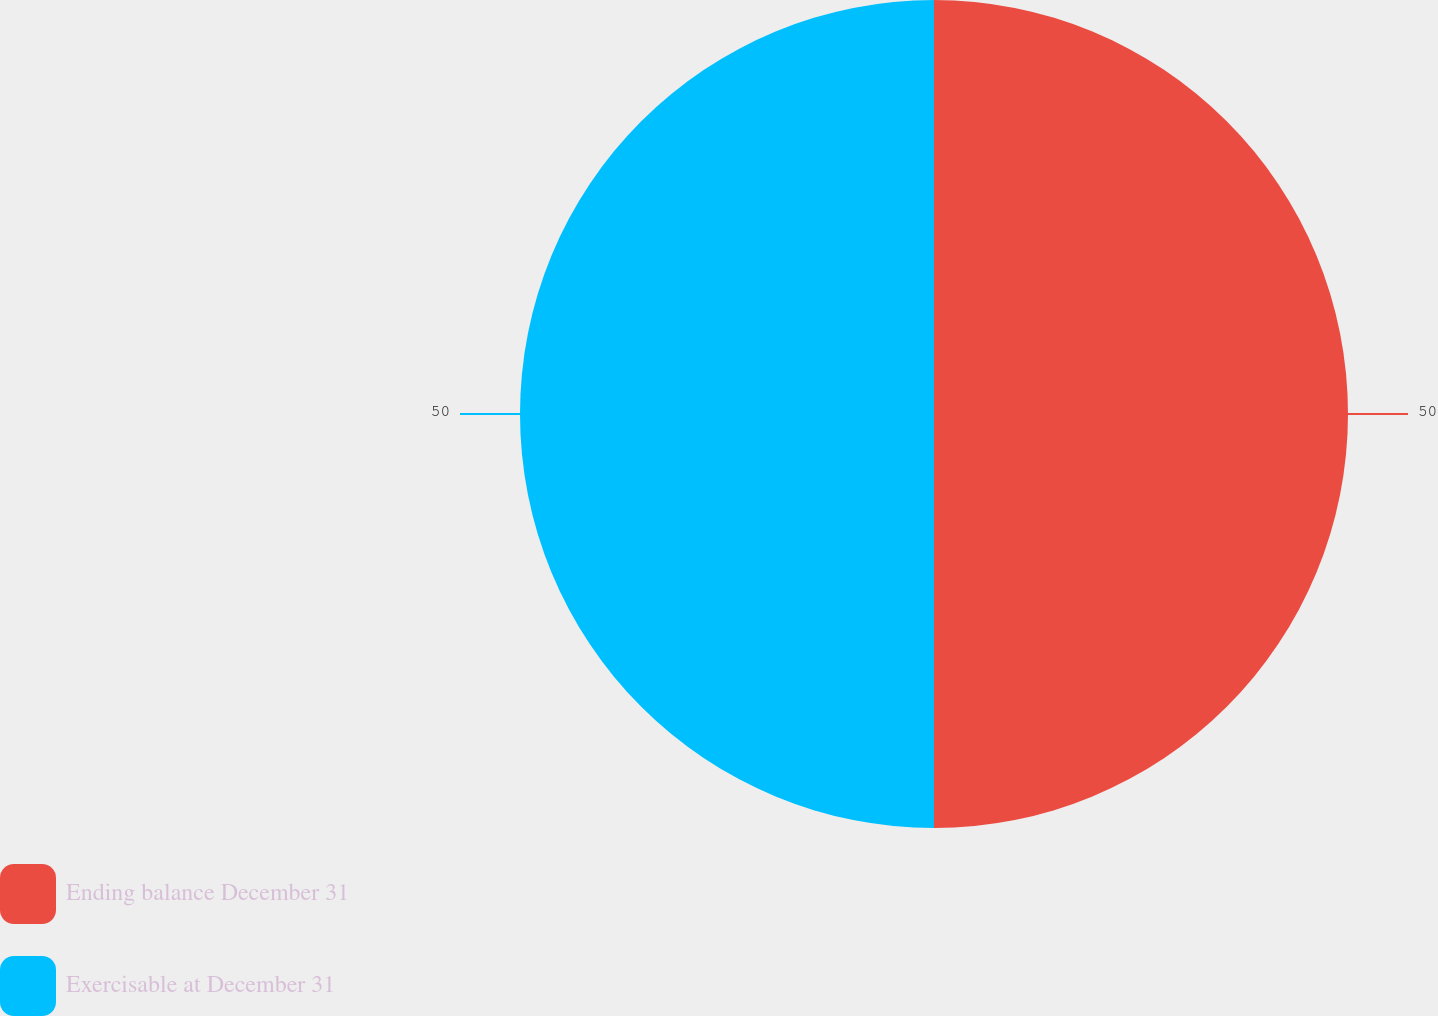<chart> <loc_0><loc_0><loc_500><loc_500><pie_chart><fcel>Ending balance December 31<fcel>Exercisable at December 31<nl><fcel>50.0%<fcel>50.0%<nl></chart> 